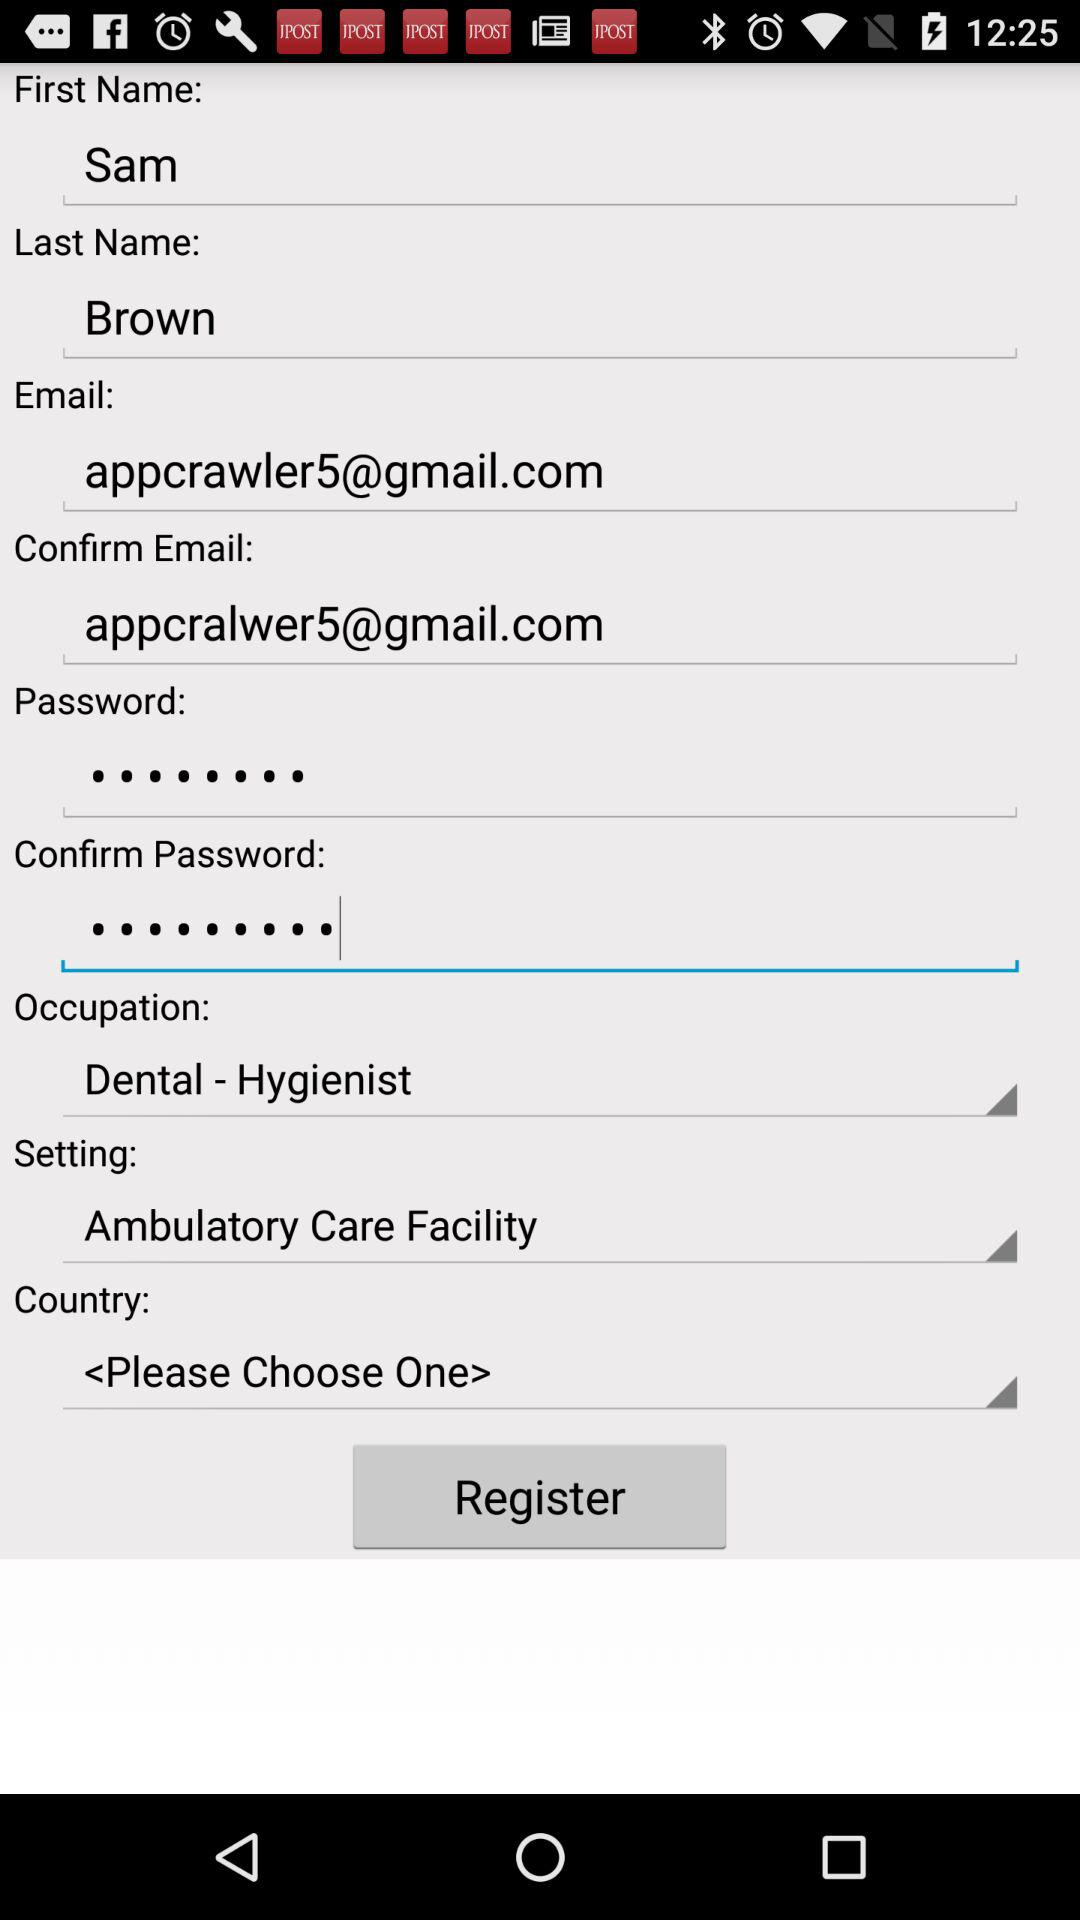What is the status of the setting? The status is ambulatory care facility. 